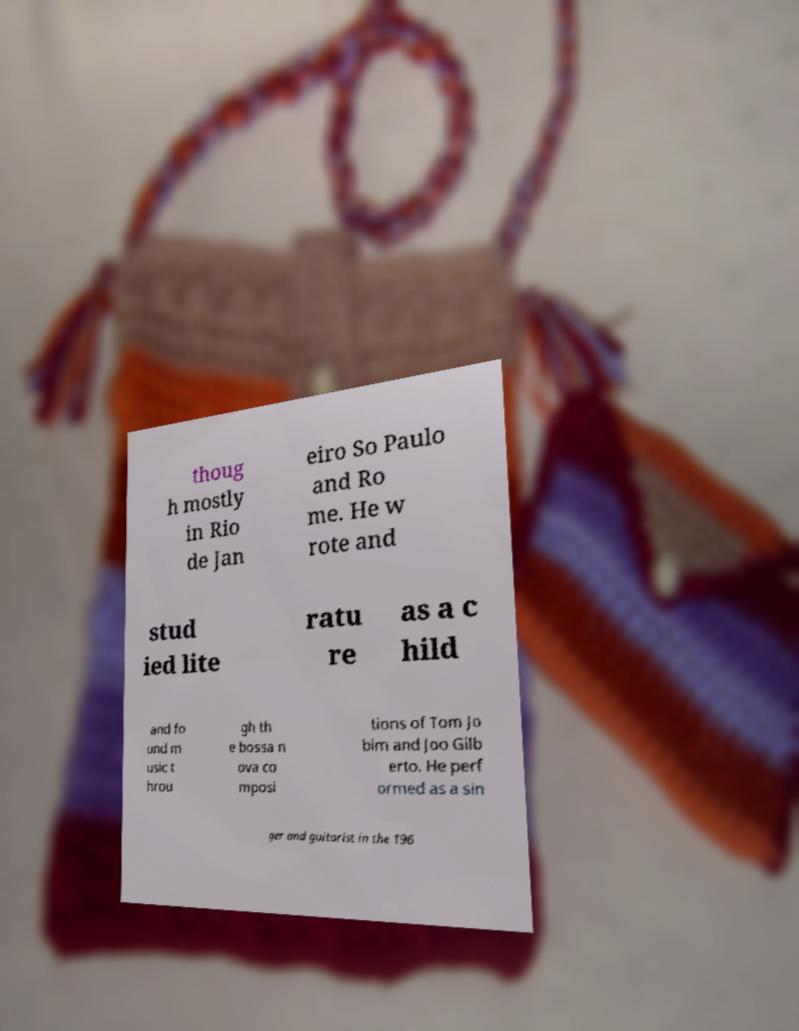Could you assist in decoding the text presented in this image and type it out clearly? thoug h mostly in Rio de Jan eiro So Paulo and Ro me. He w rote and stud ied lite ratu re as a c hild and fo und m usic t hrou gh th e bossa n ova co mposi tions of Tom Jo bim and Joo Gilb erto. He perf ormed as a sin ger and guitarist in the 196 